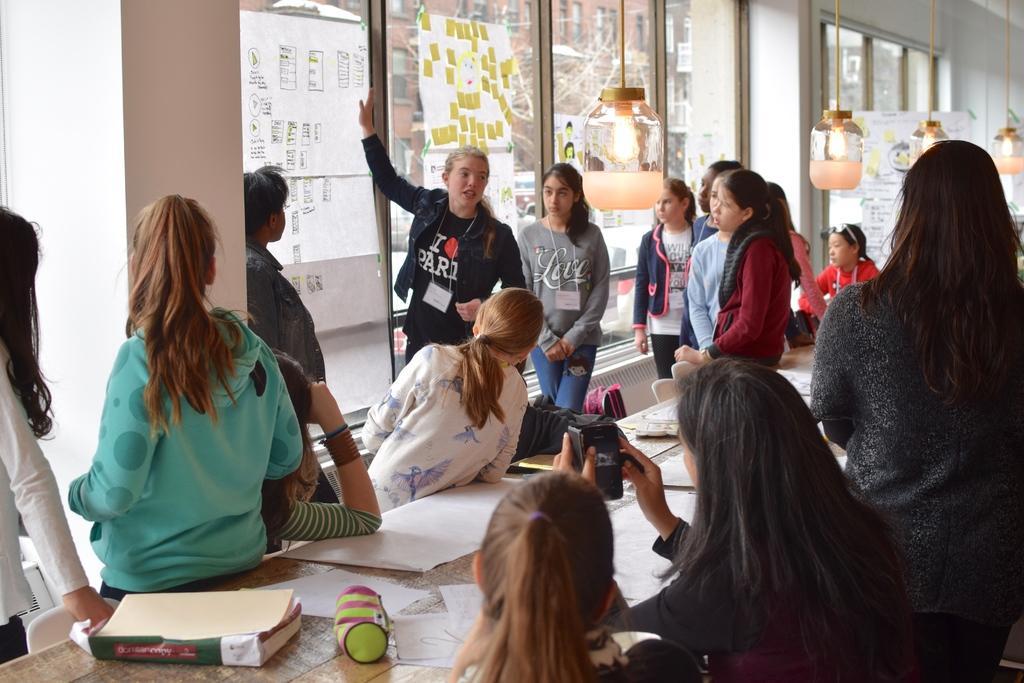In one or two sentences, can you explain what this image depicts? This picture is clicked inside the hall and we can see the group of persons and we can see a person seems to be sitting on the chair and holding some object, we can see a book, pouch and the papers and some other objects are placed on the top of the table and we can see the lamps hanging and we can see the group of persons standing. In the background we can see the windows and through the windows we can see the buildings and some other objects and we can see the bags, chairs and some other objects. 